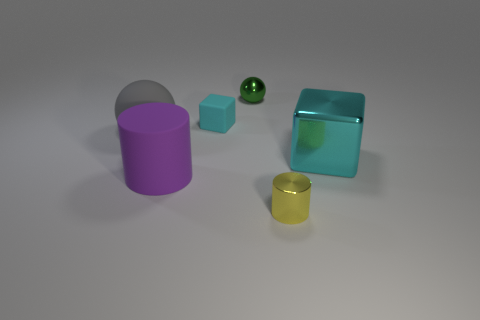Add 1 cyan blocks. How many objects exist? 7 Subtract all yellow cylinders. How many cylinders are left? 1 Subtract 1 cylinders. How many cylinders are left? 1 Add 4 gray matte balls. How many gray matte balls are left? 5 Add 1 green metallic cylinders. How many green metallic cylinders exist? 1 Subtract 0 blue blocks. How many objects are left? 6 Subtract all yellow blocks. Subtract all purple cylinders. How many blocks are left? 2 Subtract all brown spheres. How many cyan cylinders are left? 0 Subtract all green metal spheres. Subtract all large green rubber balls. How many objects are left? 5 